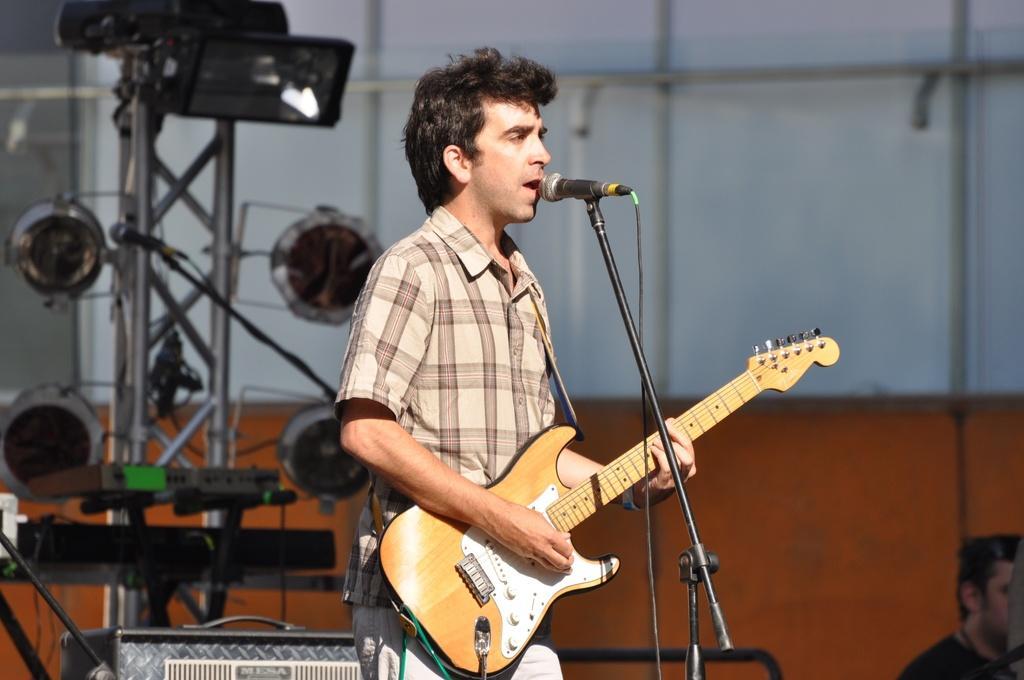How would you summarize this image in a sentence or two? In this picture we can see man holding guitar in his hand and singing on mic in a standing position and right side we can see a man in background we can see pole with lights and musical instruments. 